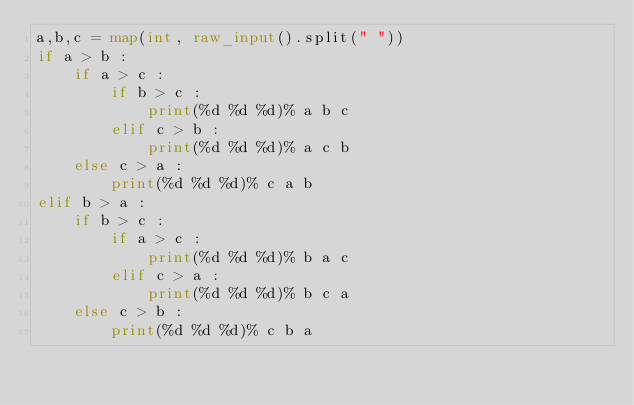<code> <loc_0><loc_0><loc_500><loc_500><_Python_>a,b,c = map(int, raw_input().split(" "))
if a > b :
    if a > c :
        if b > c :
            print(%d %d %d)% a b c
        elif c > b :
            print(%d %d %d)% a c b
    else c > a :
        print(%d %d %d)% c a b
elif b > a :
    if b > c :
        if a > c :
            print(%d %d %d)% b a c
        elif c > a :
            print(%d %d %d)% b c a
    else c > b :
        print(%d %d %d)% c b a</code> 